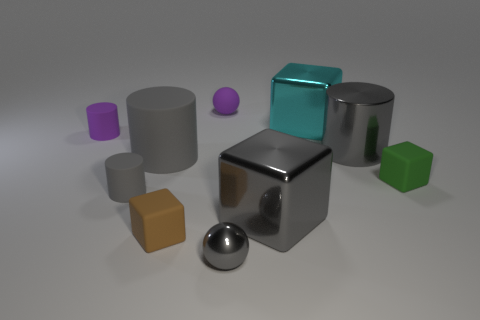Subtract all yellow spheres. How many gray cylinders are left? 3 Subtract 1 cylinders. How many cylinders are left? 3 Subtract all cylinders. How many objects are left? 6 Subtract all small gray rubber balls. Subtract all big cylinders. How many objects are left? 8 Add 2 gray rubber things. How many gray rubber things are left? 4 Add 2 green balls. How many green balls exist? 2 Subtract 3 gray cylinders. How many objects are left? 7 